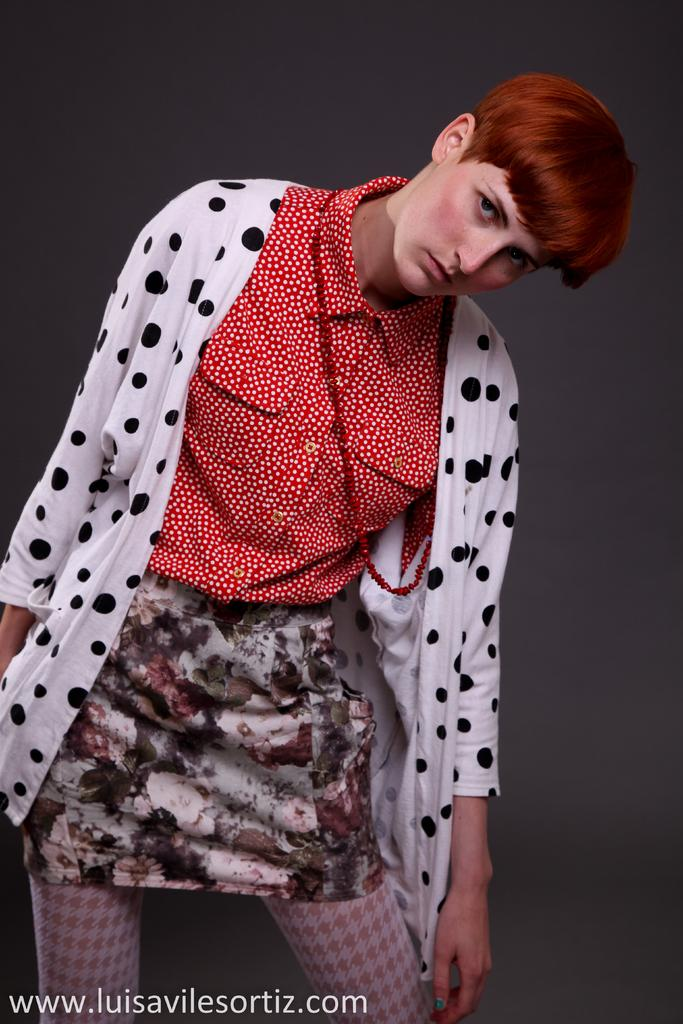What is the main subject of the image? There is a person standing in the image. What can be seen behind the person? There is a wall behind the person. Is there any text present in the image? Yes, there is some text at the bottom of the image. What type of needle is being used by the person in the image? There is no needle present in the image; the person is simply standing. What is the value of the land depicted in the image? There is no land depicted in the image, only a person standing in front of a wall. 